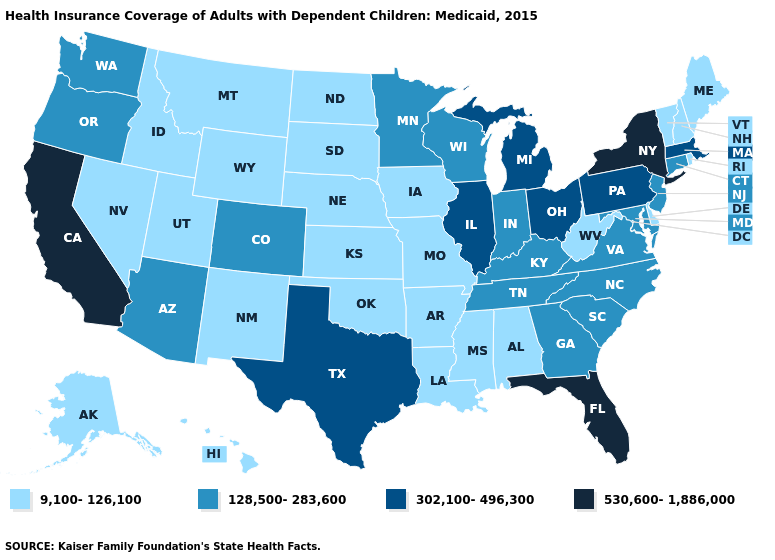What is the highest value in the Northeast ?
Give a very brief answer. 530,600-1,886,000. What is the lowest value in the USA?
Write a very short answer. 9,100-126,100. What is the lowest value in states that border Georgia?
Concise answer only. 9,100-126,100. Name the states that have a value in the range 9,100-126,100?
Write a very short answer. Alabama, Alaska, Arkansas, Delaware, Hawaii, Idaho, Iowa, Kansas, Louisiana, Maine, Mississippi, Missouri, Montana, Nebraska, Nevada, New Hampshire, New Mexico, North Dakota, Oklahoma, Rhode Island, South Dakota, Utah, Vermont, West Virginia, Wyoming. Name the states that have a value in the range 9,100-126,100?
Concise answer only. Alabama, Alaska, Arkansas, Delaware, Hawaii, Idaho, Iowa, Kansas, Louisiana, Maine, Mississippi, Missouri, Montana, Nebraska, Nevada, New Hampshire, New Mexico, North Dakota, Oklahoma, Rhode Island, South Dakota, Utah, Vermont, West Virginia, Wyoming. Name the states that have a value in the range 9,100-126,100?
Short answer required. Alabama, Alaska, Arkansas, Delaware, Hawaii, Idaho, Iowa, Kansas, Louisiana, Maine, Mississippi, Missouri, Montana, Nebraska, Nevada, New Hampshire, New Mexico, North Dakota, Oklahoma, Rhode Island, South Dakota, Utah, Vermont, West Virginia, Wyoming. What is the highest value in the MidWest ?
Answer briefly. 302,100-496,300. What is the value of Rhode Island?
Keep it brief. 9,100-126,100. Does Virginia have the lowest value in the South?
Give a very brief answer. No. What is the value of Connecticut?
Write a very short answer. 128,500-283,600. Name the states that have a value in the range 128,500-283,600?
Short answer required. Arizona, Colorado, Connecticut, Georgia, Indiana, Kentucky, Maryland, Minnesota, New Jersey, North Carolina, Oregon, South Carolina, Tennessee, Virginia, Washington, Wisconsin. What is the value of Massachusetts?
Give a very brief answer. 302,100-496,300. Name the states that have a value in the range 128,500-283,600?
Write a very short answer. Arizona, Colorado, Connecticut, Georgia, Indiana, Kentucky, Maryland, Minnesota, New Jersey, North Carolina, Oregon, South Carolina, Tennessee, Virginia, Washington, Wisconsin. Among the states that border Connecticut , which have the lowest value?
Short answer required. Rhode Island. What is the value of Utah?
Short answer required. 9,100-126,100. 